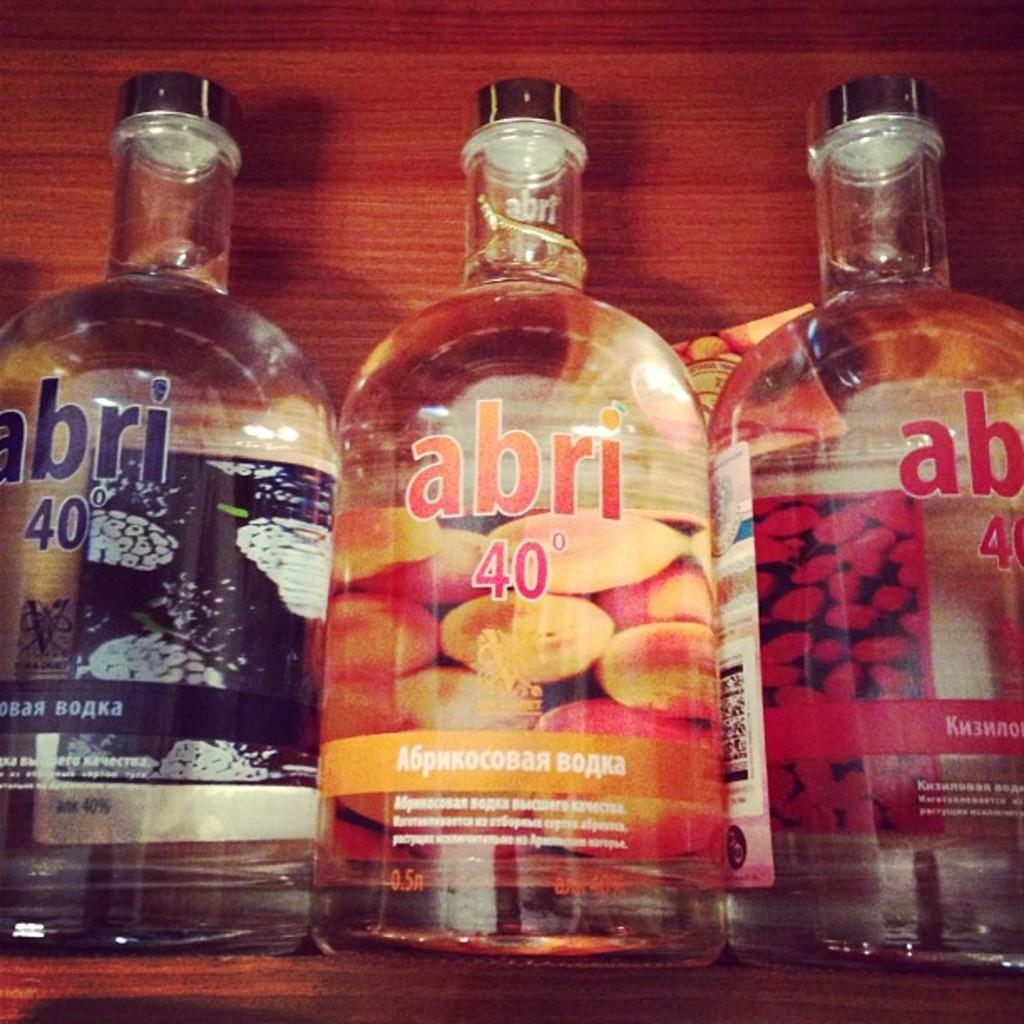<image>
Offer a succinct explanation of the picture presented. Three different flavored bottles of abri 40 proof alcohol sit on a wood shelf. 